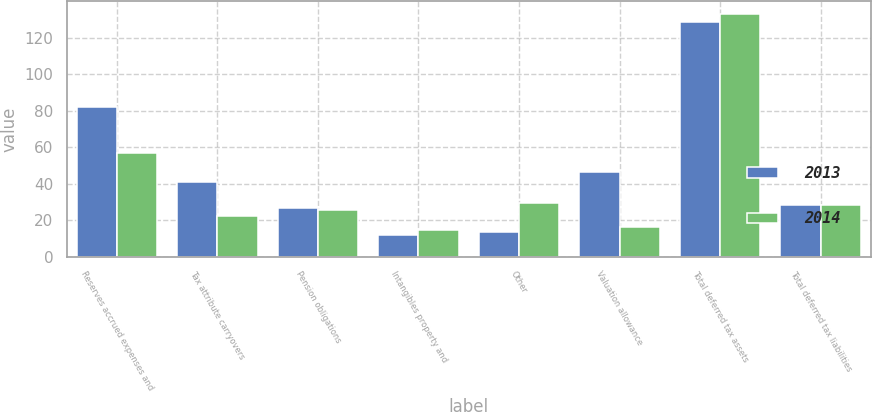<chart> <loc_0><loc_0><loc_500><loc_500><stacked_bar_chart><ecel><fcel>Reserves accrued expenses and<fcel>Tax attribute carryovers<fcel>Pension obligations<fcel>Intangibles property and<fcel>Other<fcel>Valuation allowance<fcel>Total deferred tax assets<fcel>Total deferred tax liabilities<nl><fcel>2013<fcel>81.8<fcel>41<fcel>26.7<fcel>12.1<fcel>13.6<fcel>46.6<fcel>128.6<fcel>28.2<nl><fcel>2014<fcel>57<fcel>22.3<fcel>25.6<fcel>14.9<fcel>29.7<fcel>16.4<fcel>133.1<fcel>28.2<nl></chart> 